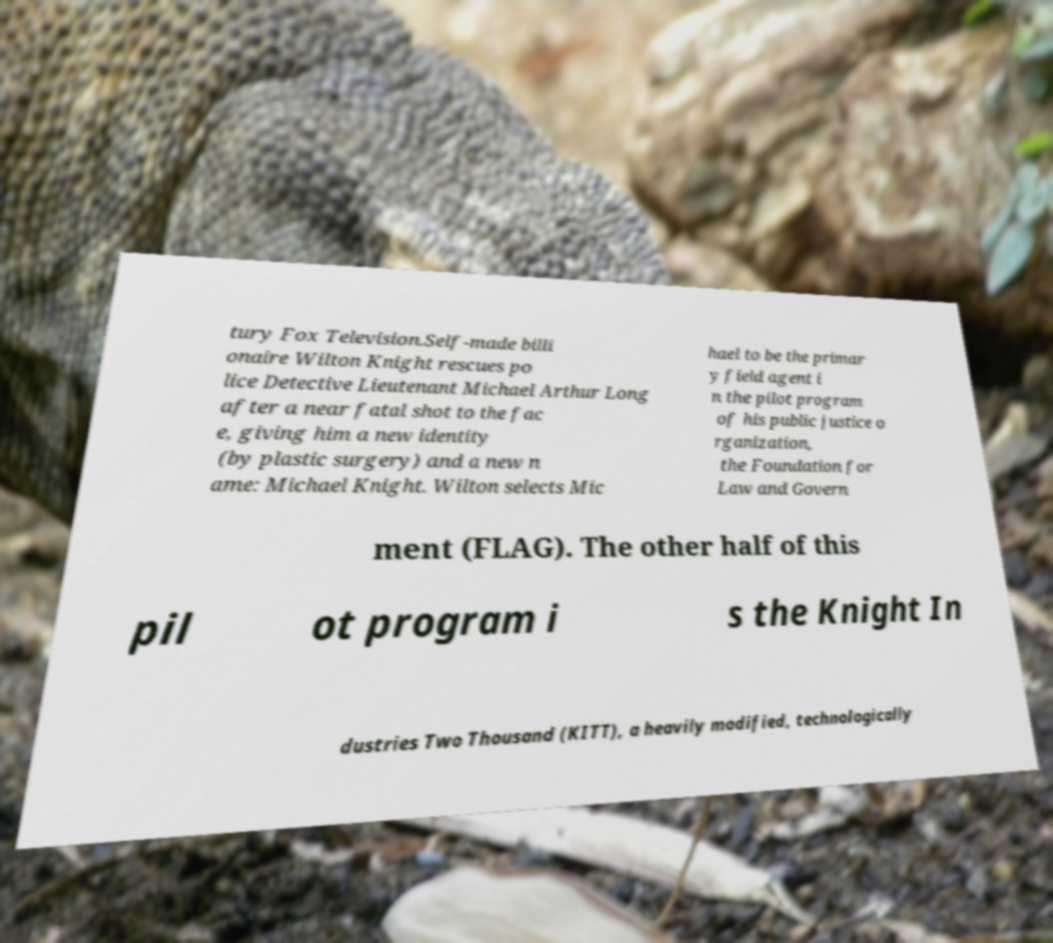For documentation purposes, I need the text within this image transcribed. Could you provide that? tury Fox Television.Self-made billi onaire Wilton Knight rescues po lice Detective Lieutenant Michael Arthur Long after a near fatal shot to the fac e, giving him a new identity (by plastic surgery) and a new n ame: Michael Knight. Wilton selects Mic hael to be the primar y field agent i n the pilot program of his public justice o rganization, the Foundation for Law and Govern ment (FLAG). The other half of this pil ot program i s the Knight In dustries Two Thousand (KITT), a heavily modified, technologically 